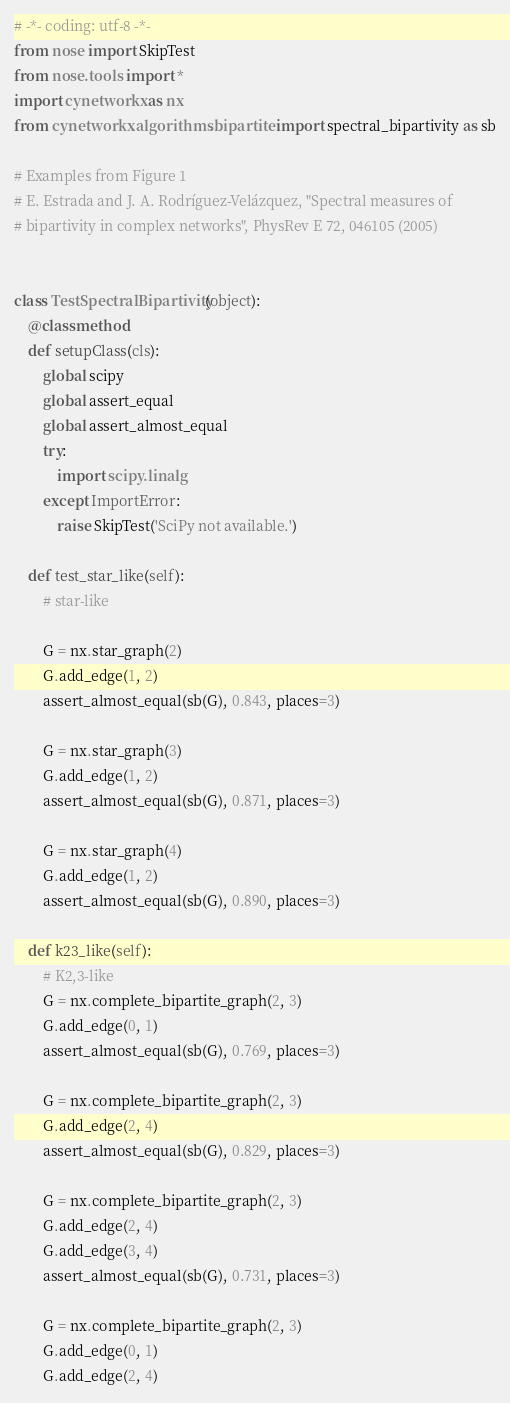Convert code to text. <code><loc_0><loc_0><loc_500><loc_500><_Python_># -*- coding: utf-8 -*-
from nose import SkipTest
from nose.tools import *
import cynetworkx as nx
from cynetworkx.algorithms.bipartite import spectral_bipartivity as sb

# Examples from Figure 1
# E. Estrada and J. A. Rodríguez-Velázquez, "Spectral measures of
# bipartivity in complex networks", PhysRev E 72, 046105 (2005)


class TestSpectralBipartivity(object):
    @classmethod
    def setupClass(cls):
        global scipy
        global assert_equal
        global assert_almost_equal
        try:
            import scipy.linalg
        except ImportError:
            raise SkipTest('SciPy not available.')

    def test_star_like(self):
        # star-like

        G = nx.star_graph(2)
        G.add_edge(1, 2)
        assert_almost_equal(sb(G), 0.843, places=3)

        G = nx.star_graph(3)
        G.add_edge(1, 2)
        assert_almost_equal(sb(G), 0.871, places=3)

        G = nx.star_graph(4)
        G.add_edge(1, 2)
        assert_almost_equal(sb(G), 0.890, places=3)

    def k23_like(self):
        # K2,3-like
        G = nx.complete_bipartite_graph(2, 3)
        G.add_edge(0, 1)
        assert_almost_equal(sb(G), 0.769, places=3)

        G = nx.complete_bipartite_graph(2, 3)
        G.add_edge(2, 4)
        assert_almost_equal(sb(G), 0.829, places=3)

        G = nx.complete_bipartite_graph(2, 3)
        G.add_edge(2, 4)
        G.add_edge(3, 4)
        assert_almost_equal(sb(G), 0.731, places=3)

        G = nx.complete_bipartite_graph(2, 3)
        G.add_edge(0, 1)
        G.add_edge(2, 4)</code> 